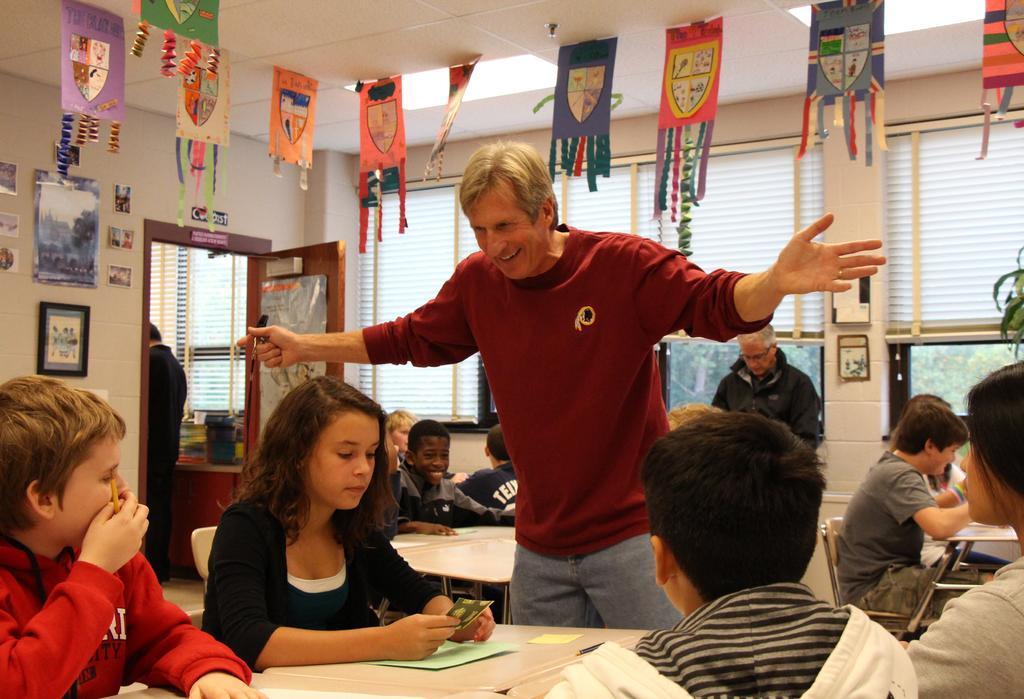Can you describe this image briefly? In this image we can see a person standing on the floor and some children sitting on the chairs. On the backside we can see a roof, ceiling lights, papers with ribbons, door, a person standing beside the door, a photo frame and the wall. 